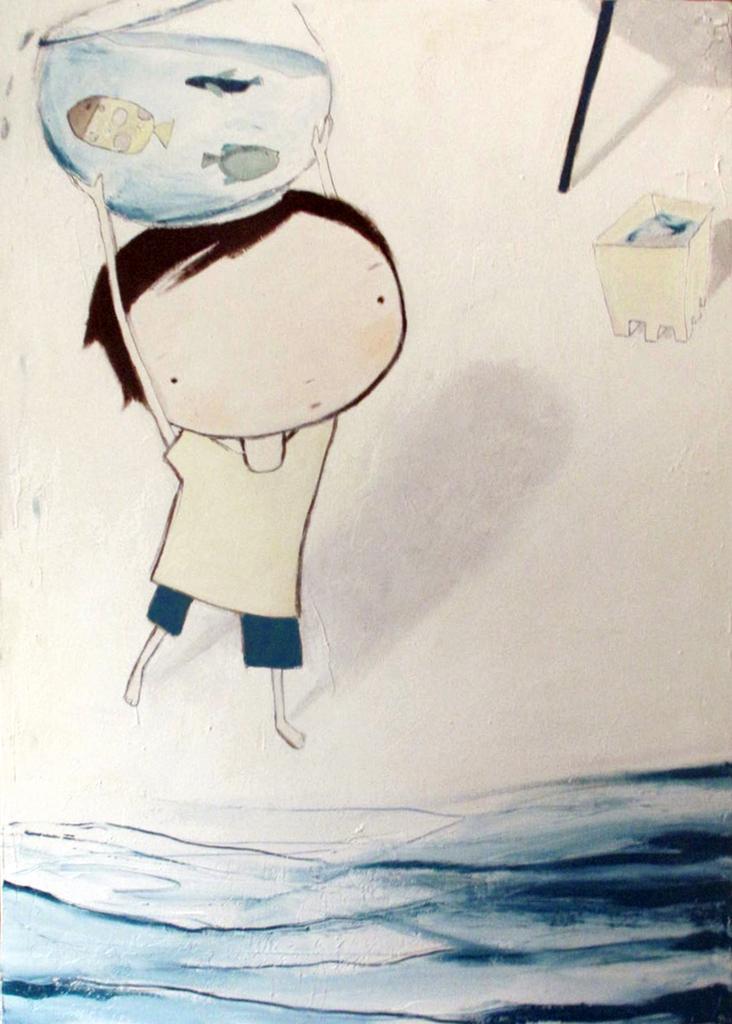In one or two sentences, can you explain what this image depicts? In this image there is an art in which there is a boy holding an aquarium. In front of him there is water. In the aquarium there are fishes. 